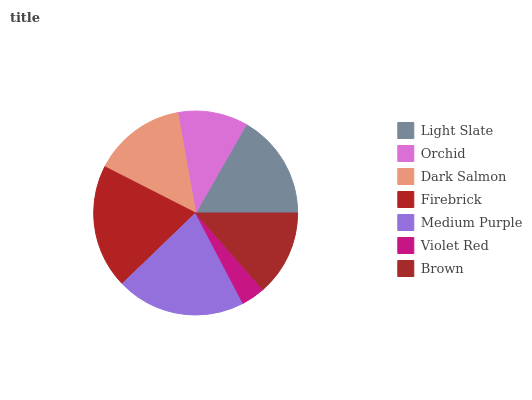Is Violet Red the minimum?
Answer yes or no. Yes. Is Medium Purple the maximum?
Answer yes or no. Yes. Is Orchid the minimum?
Answer yes or no. No. Is Orchid the maximum?
Answer yes or no. No. Is Light Slate greater than Orchid?
Answer yes or no. Yes. Is Orchid less than Light Slate?
Answer yes or no. Yes. Is Orchid greater than Light Slate?
Answer yes or no. No. Is Light Slate less than Orchid?
Answer yes or no. No. Is Dark Salmon the high median?
Answer yes or no. Yes. Is Dark Salmon the low median?
Answer yes or no. Yes. Is Firebrick the high median?
Answer yes or no. No. Is Orchid the low median?
Answer yes or no. No. 